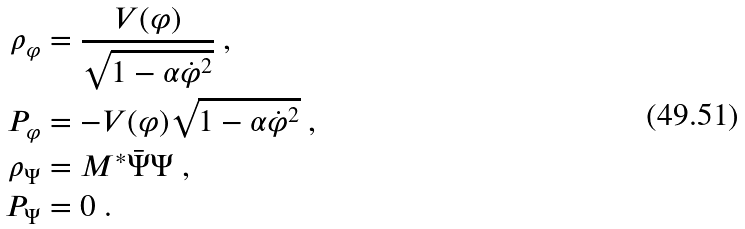<formula> <loc_0><loc_0><loc_500><loc_500>\rho _ { \varphi } & = \frac { V ( \varphi ) } { \sqrt { 1 - \alpha \dot { \varphi } ^ { 2 } } } \text { ,} \\ P _ { \varphi } & = - V ( \varphi ) \sqrt { 1 - \alpha \dot { \varphi } ^ { 2 } } \text { ,} \\ \rho _ { \Psi } & = M ^ { \ast } \bar { \Psi } \Psi \text { ,} \\ P _ { \Psi } & = 0 \text { .}</formula> 